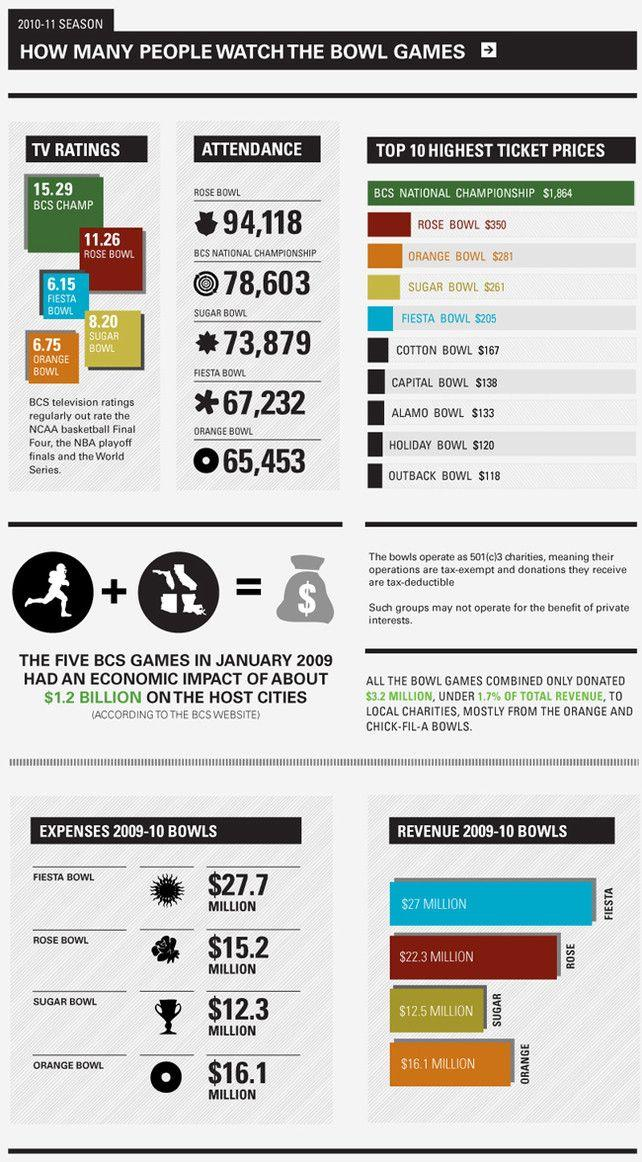Indicate a few pertinent items in this graphic. The ticket price difference between the Sugar Bowl and the Cotton Bowl is $94. The revenue generated from the 2009-2010 Rose Bowl was significantly higher than the revenue generated from the 2009-2010 Sugar Bowl, resulting in a difference of $9.8 million. The number of people who attended the Fiesta Bowl was higher than those who attended the Orange Bowl by 1779. In the 2009-2010 season, the Fiesta Bowl generated significantly more revenue than the Sugar Bowl, a staggering $14.5 million more, to be precise. The difference in ticket price between the Capital One Bowl and the Holiday Bowl is $18. 